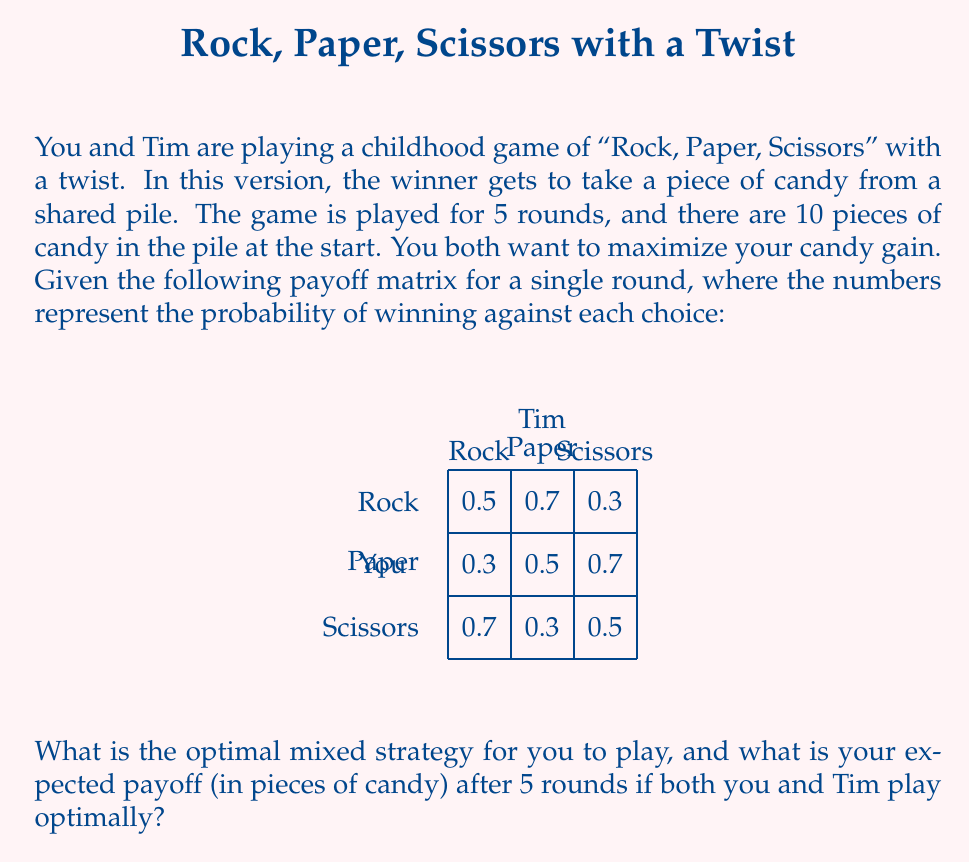Solve this math problem. Let's approach this step-by-step:

1) First, we need to find the Nash equilibrium for this game. In a symmetric game like this, both players will have the same mixed strategy at equilibrium.

2) Let's define $p$, $q$, and $r$ as the probabilities of playing Rock, Paper, and Scissors respectively. We know that $p + q + r = 1$.

3) For a mixed strategy to be optimal, the expected payoff for each pure strategy should be equal. Let's set up these equations:

   $$0.5p + 0.3q + 0.7r = 0.7p + 0.5q + 0.3r = 0.3p + 0.7q + 0.5r$$

4) Simplifying the first two equations:
   $$0.2p = 0.4r$$
   $$p = 2r$$

5) Substituting this into $p + q + r = 1$:
   $$2r + q + r = 1$$
   $$3r + q = 1$$

6) From the last two equations in step 3:
   $$0.4p + 0.2q = 0.4q + 0.2r$$
   $$0.4(2r) + 0.2q = 0.4q + 0.2r$$
   $$0.8r + 0.2q = 0.4q + 0.2r$$
   $$0.6r = 0.2q$$
   $$3r = q$$

7) Substituting this into the equation from step 5:
   $$3r + 3r = 1$$
   $$6r = 1$$
   $$r = \frac{1}{6}$$

8) Therefore, $q = \frac{1}{2}$ and $p = \frac{1}{3}$

9) The optimal mixed strategy is $(\frac{1}{3}, \frac{1}{2}, \frac{1}{6})$ for (Rock, Paper, Scissors).

10) To calculate the expected payoff, we need to find the probability of winning a single round when both players use this strategy:

    $$(\frac{1}{3} \cdot 0.5 + \frac{1}{2} \cdot 0.3 + \frac{1}{6} \cdot 0.7) \cdot \frac{1}{3} + (\frac{1}{3} \cdot 0.7 + \frac{1}{2} \cdot 0.5 + \frac{1}{6} \cdot 0.3) \cdot \frac{1}{2} + (\frac{1}{3} \cdot 0.3 + \frac{1}{2} \cdot 0.7 + \frac{1}{6} \cdot 0.5) \cdot \frac{1}{6} = 0.5$$

11) This means in each round, you have a 50% chance of winning one piece of candy.

12) Over 5 rounds, your expected payoff is $5 \cdot 0.5 = 2.5$ pieces of candy.
Answer: $(\frac{1}{3}, \frac{1}{2}, \frac{1}{6})$; 2.5 pieces of candy 